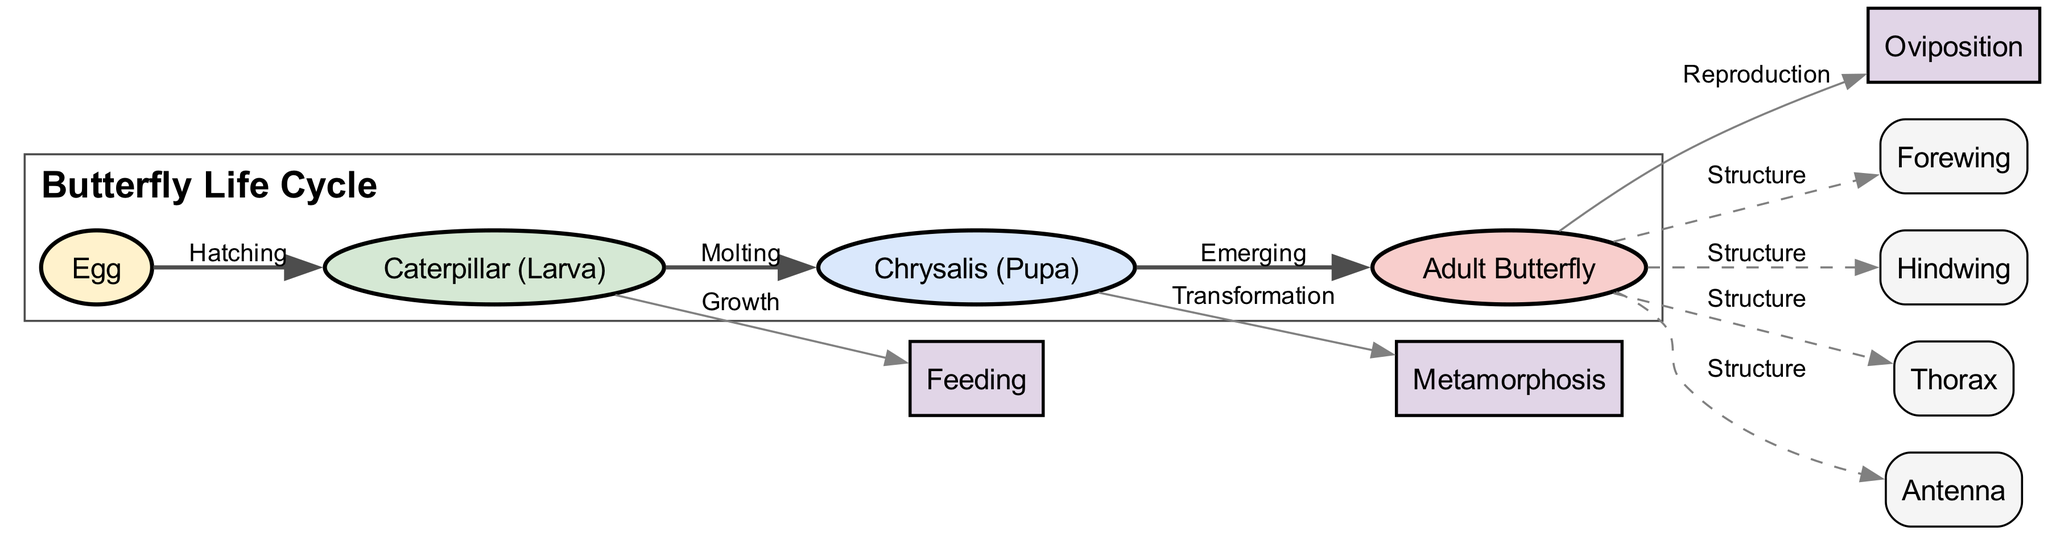What are the four life stages of a butterfly? The diagram lists four main life stages: Egg, Caterpillar (Larva), Chrysalis (Pupa), and Adult Butterfly.
Answer: Egg, Caterpillar, Chrysalis, Adult Butterfly How many edges are in the diagram? Counting the connections (edges) between the nodes, there are a total of 9 edges connecting different life stages and structures.
Answer: 9 What process occurs between the caterpillar and the pupa? The diagram shows that the process connecting the Caterpillar and the Pupa is called "Molting."
Answer: Molting Which life stage directly leads to reproduction? The Adult Butterfly stage leads to the process of Reproduction, as indicated by the arrow pointing from "Adult Butterfly" to "Oviposition."
Answer: Adult Butterfly What is the transformation process occurring in the pupa stage? In the diagram, the transformation process happening during the Pupa stage is labeled as "Metamorphosis."
Answer: Metamorphosis Which node does the larva connect to for growth? The arrow from the Caterpillar (Larva) points to the "Feeding" process, indicating this connection.
Answer: Feeding How many structures are identified for the adult butterfly? The diagram identifies four structures connected to the Adult Butterfly: Forewing, Hindwing, Thorax, and Antenna.
Answer: 4 What relationship does the egg have with the larva? The Egg stage connects to the Larva stage through the action "Hatching," showing the direct relationship between them.
Answer: Hatching What type of butterfly is primarily represented in the diagram? The diagram represents the general life cycle of a butterfly, which includes all its distinct life stages.
Answer: Butterfly 